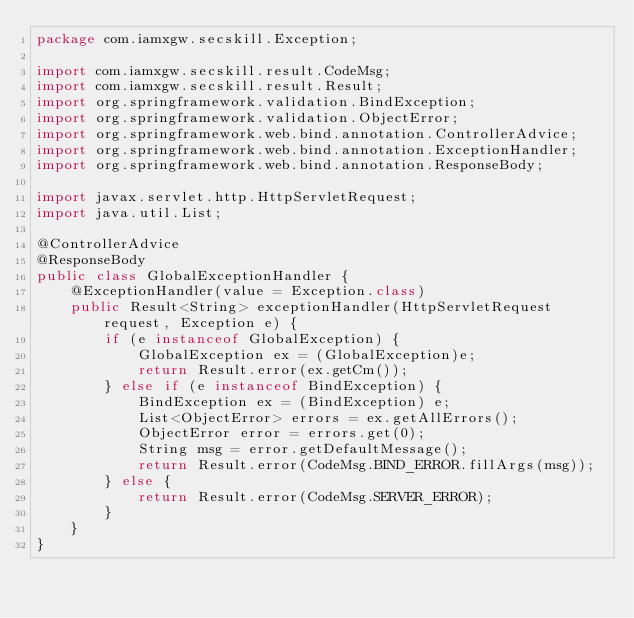Convert code to text. <code><loc_0><loc_0><loc_500><loc_500><_Java_>package com.iamxgw.secskill.Exception;

import com.iamxgw.secskill.result.CodeMsg;
import com.iamxgw.secskill.result.Result;
import org.springframework.validation.BindException;
import org.springframework.validation.ObjectError;
import org.springframework.web.bind.annotation.ControllerAdvice;
import org.springframework.web.bind.annotation.ExceptionHandler;
import org.springframework.web.bind.annotation.ResponseBody;

import javax.servlet.http.HttpServletRequest;
import java.util.List;

@ControllerAdvice
@ResponseBody
public class GlobalExceptionHandler {
    @ExceptionHandler(value = Exception.class)
    public Result<String> exceptionHandler(HttpServletRequest request, Exception e) {
        if (e instanceof GlobalException) {
            GlobalException ex = (GlobalException)e;
            return Result.error(ex.getCm());
        } else if (e instanceof BindException) {
            BindException ex = (BindException) e;
            List<ObjectError> errors = ex.getAllErrors();
            ObjectError error = errors.get(0);
            String msg = error.getDefaultMessage();
            return Result.error(CodeMsg.BIND_ERROR.fillArgs(msg));
        } else {
            return Result.error(CodeMsg.SERVER_ERROR);
        }
    }
}
</code> 